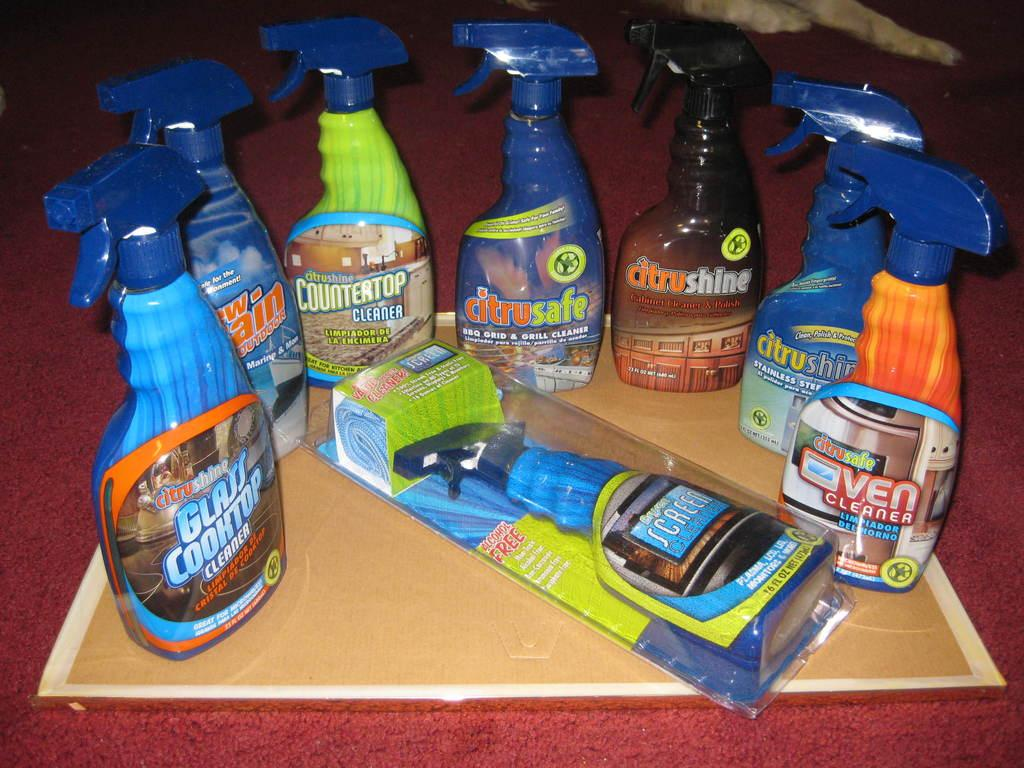<image>
Summarize the visual content of the image. Glass Cooktop cleaner in a bright blue bottle with other cleaners. 